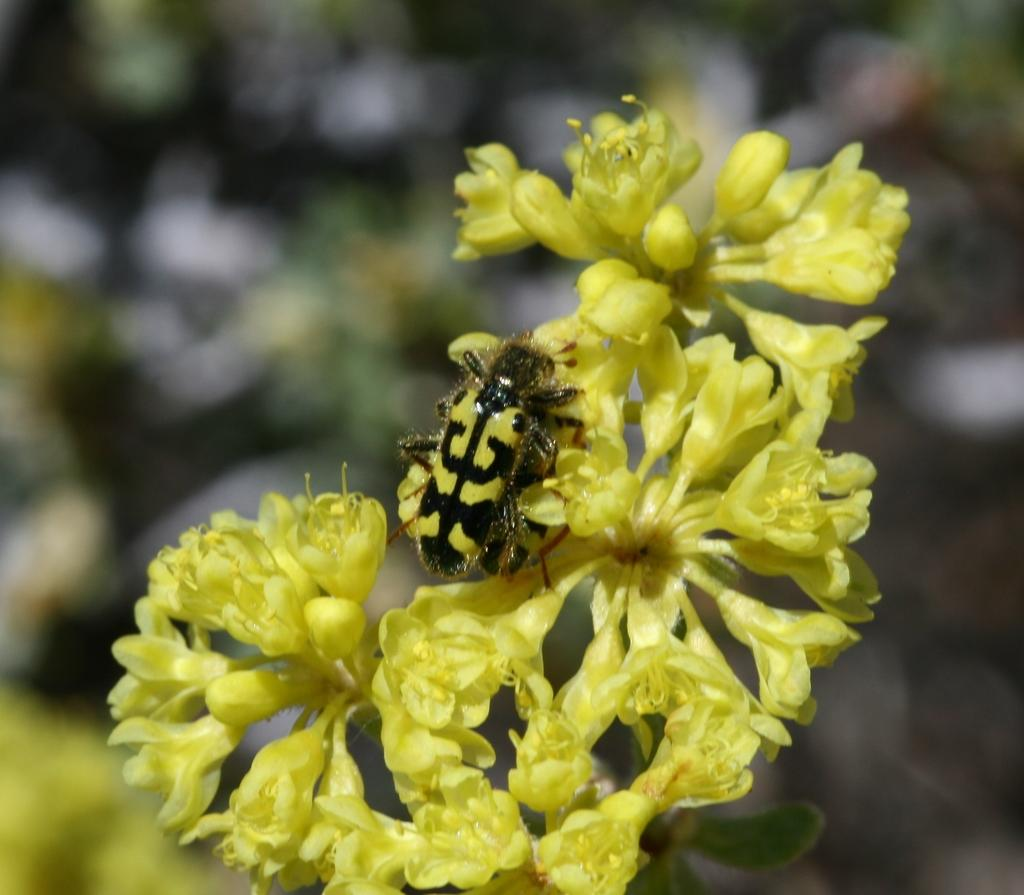What type of creature is present in the image? There is an insect in the image. What is the insect sitting on? The insect is on yellow flowers. Can you describe the background of the image? The background of the image is blurry. How many beds can be seen in the image? There are no beds present in the image. What type of owl is sitting on the squirrel in the image? There is no owl or squirrel present in the image. 